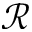<formula> <loc_0><loc_0><loc_500><loc_500>\mathcal { R }</formula> 